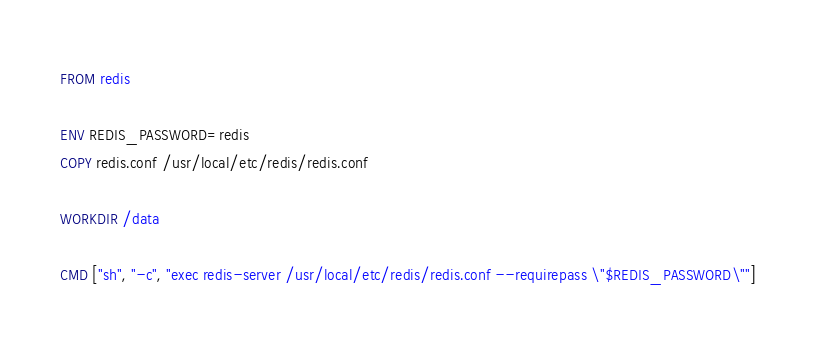<code> <loc_0><loc_0><loc_500><loc_500><_Dockerfile_>FROM redis

ENV REDIS_PASSWORD=redis
COPY redis.conf /usr/local/etc/redis/redis.conf

WORKDIR /data

CMD ["sh", "-c", "exec redis-server /usr/local/etc/redis/redis.conf --requirepass \"$REDIS_PASSWORD\""]
</code> 